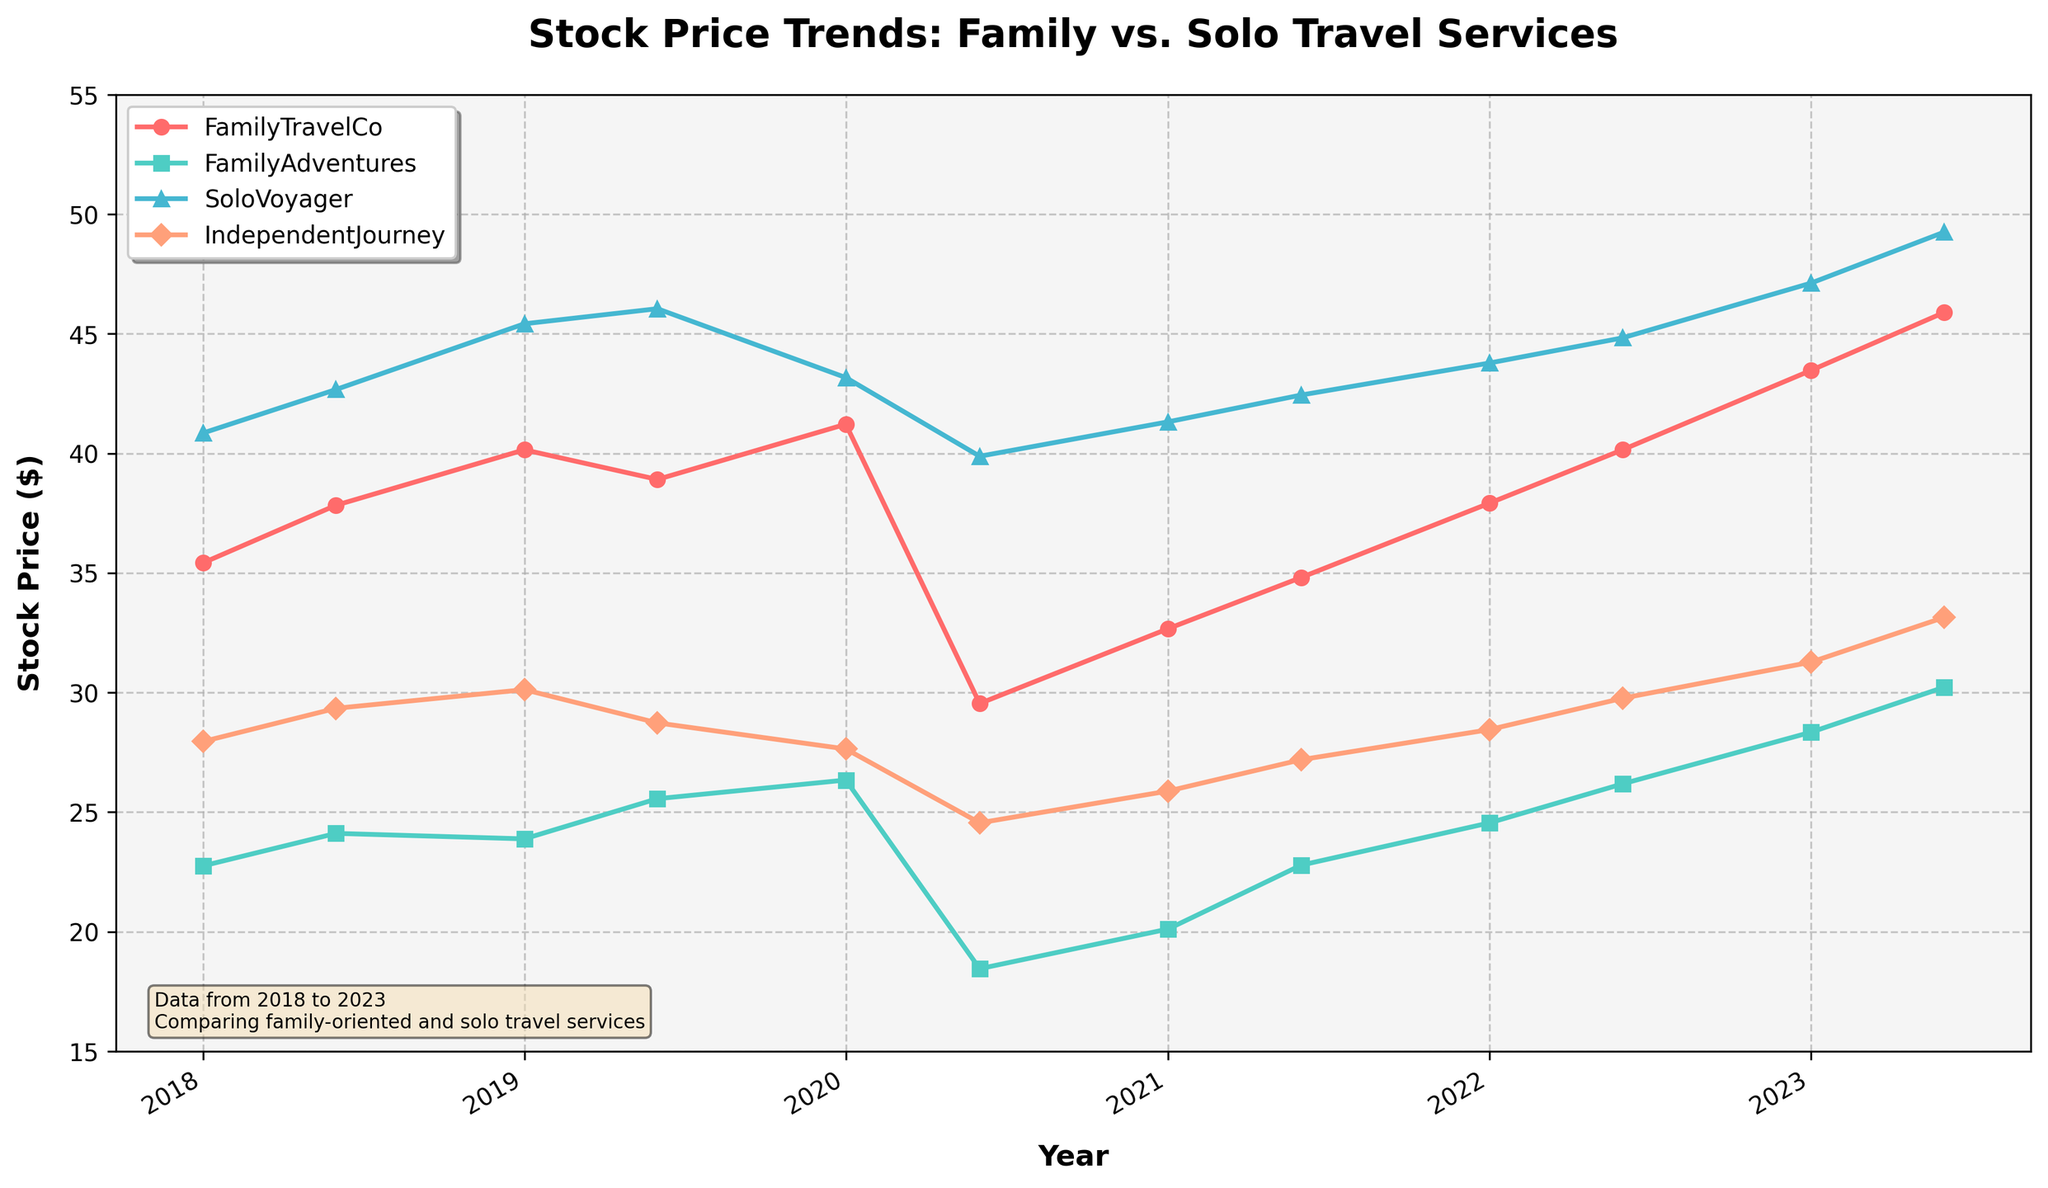What is the title of the figure? The title of the figure can be found at the top of the chart, which summarizes the content of the graph.
Answer: Stock Price Trends: Family vs. Solo Travel Services How many different travel services are compared in the figure? Count the number of different lines plotted on the figure, each representing a distinct travel service.
Answer: Four What is the stock price of FamilyTravelCo on 2020-06-01? Locate the point corresponding to 2020-06-01 on the x-axis for FamilyTravelCo's line and read the stock price value on the y-axis.
Answer: 29.54 Between FamilyTravelCo and FamilyAdventures, which company had a higher stock price on 2022-01-01? Compare the y-value of the points for FamilyTravelCo and FamilyAdventures at the x-axis value of 2022-01-01.
Answer: FamilyTravelCo How did SoloVoyager's stock price change from 2018-01-01 to 2023-06-01? Subtract the stock price of SoloVoyager on 2018-01-01 from its stock price on 2023-06-01.
Answer: Increased by 8.4 Which travel service had the lowest stock price during the COVID-19 pandemic period (2020)? Identify the lowest stock price for each travel service in 2020 and find which one is the lowest among them.
Answer: FamilyAdventures What is the average stock price of IndependentJourney across the entire period? Sum all the stock prices of IndependentJourney across all dates and divide by the number of data points.
Answer: 28.49 Did all travel services show an upward trend in stock price from 2018 to 2023? Determine if the stock prices for all travel services increased from 2018-01-01 to 2023-06-01 by comparing the initial and final values for each.
Answer: Yes Which travel service had the most significant dip in stock price between two consecutive time points? Calculate the differences in stock prices between consecutive dates for each travel service and identify the maximum decrease.
Answer: FamilyTravelCo What was the stock price trend for FamilyAdventures between 2018-06-01 and 2020-01-01? Compare the stock prices of FamilyAdventures on 2018-06-01 and 2020-01-01 to determine the trend (increasing, decreasing, or stable).
Answer: Increasing (24.11 to 26.34) 